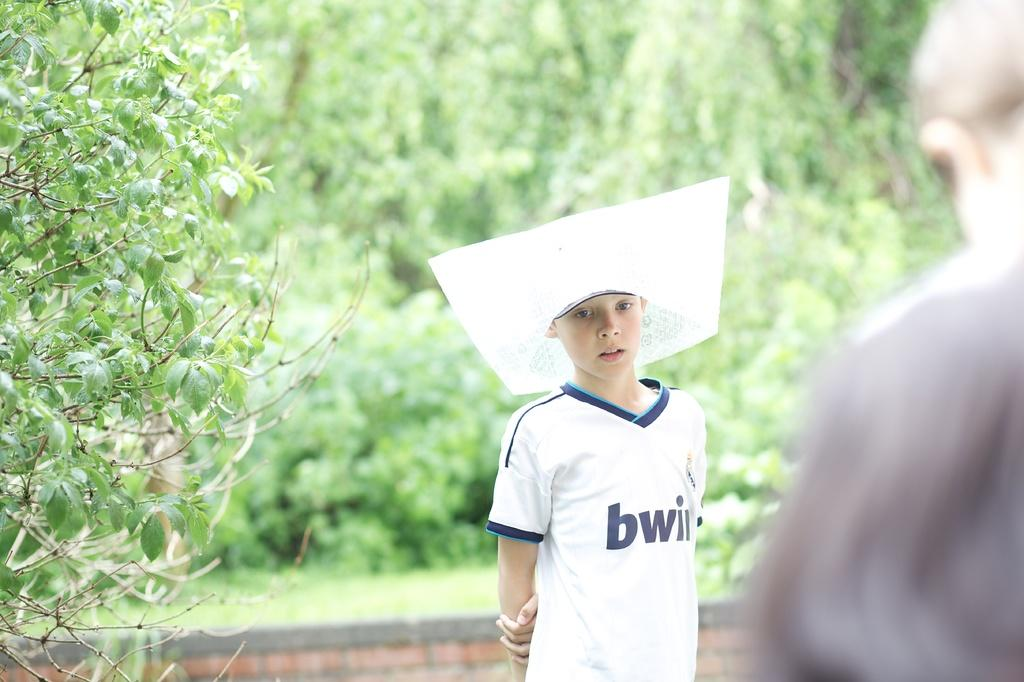Provide a one-sentence caption for the provided image. a boy in a white Tee shirt with a BWII logo in blue. 